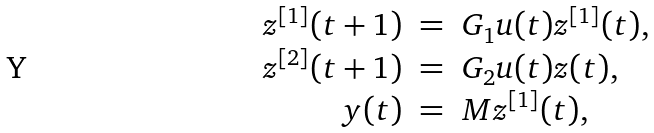<formula> <loc_0><loc_0><loc_500><loc_500>\begin{array} { r c l } z ^ { [ 1 ] } ( t + 1 ) & = & G _ { 1 } u ( t ) z ^ { [ 1 ] } ( t ) , \\ z ^ { [ 2 ] } ( t + 1 ) & = & G _ { 2 } u ( t ) z ( t ) , \\ y ( t ) & = & M z ^ { [ 1 ] } ( t ) , \end{array}</formula> 